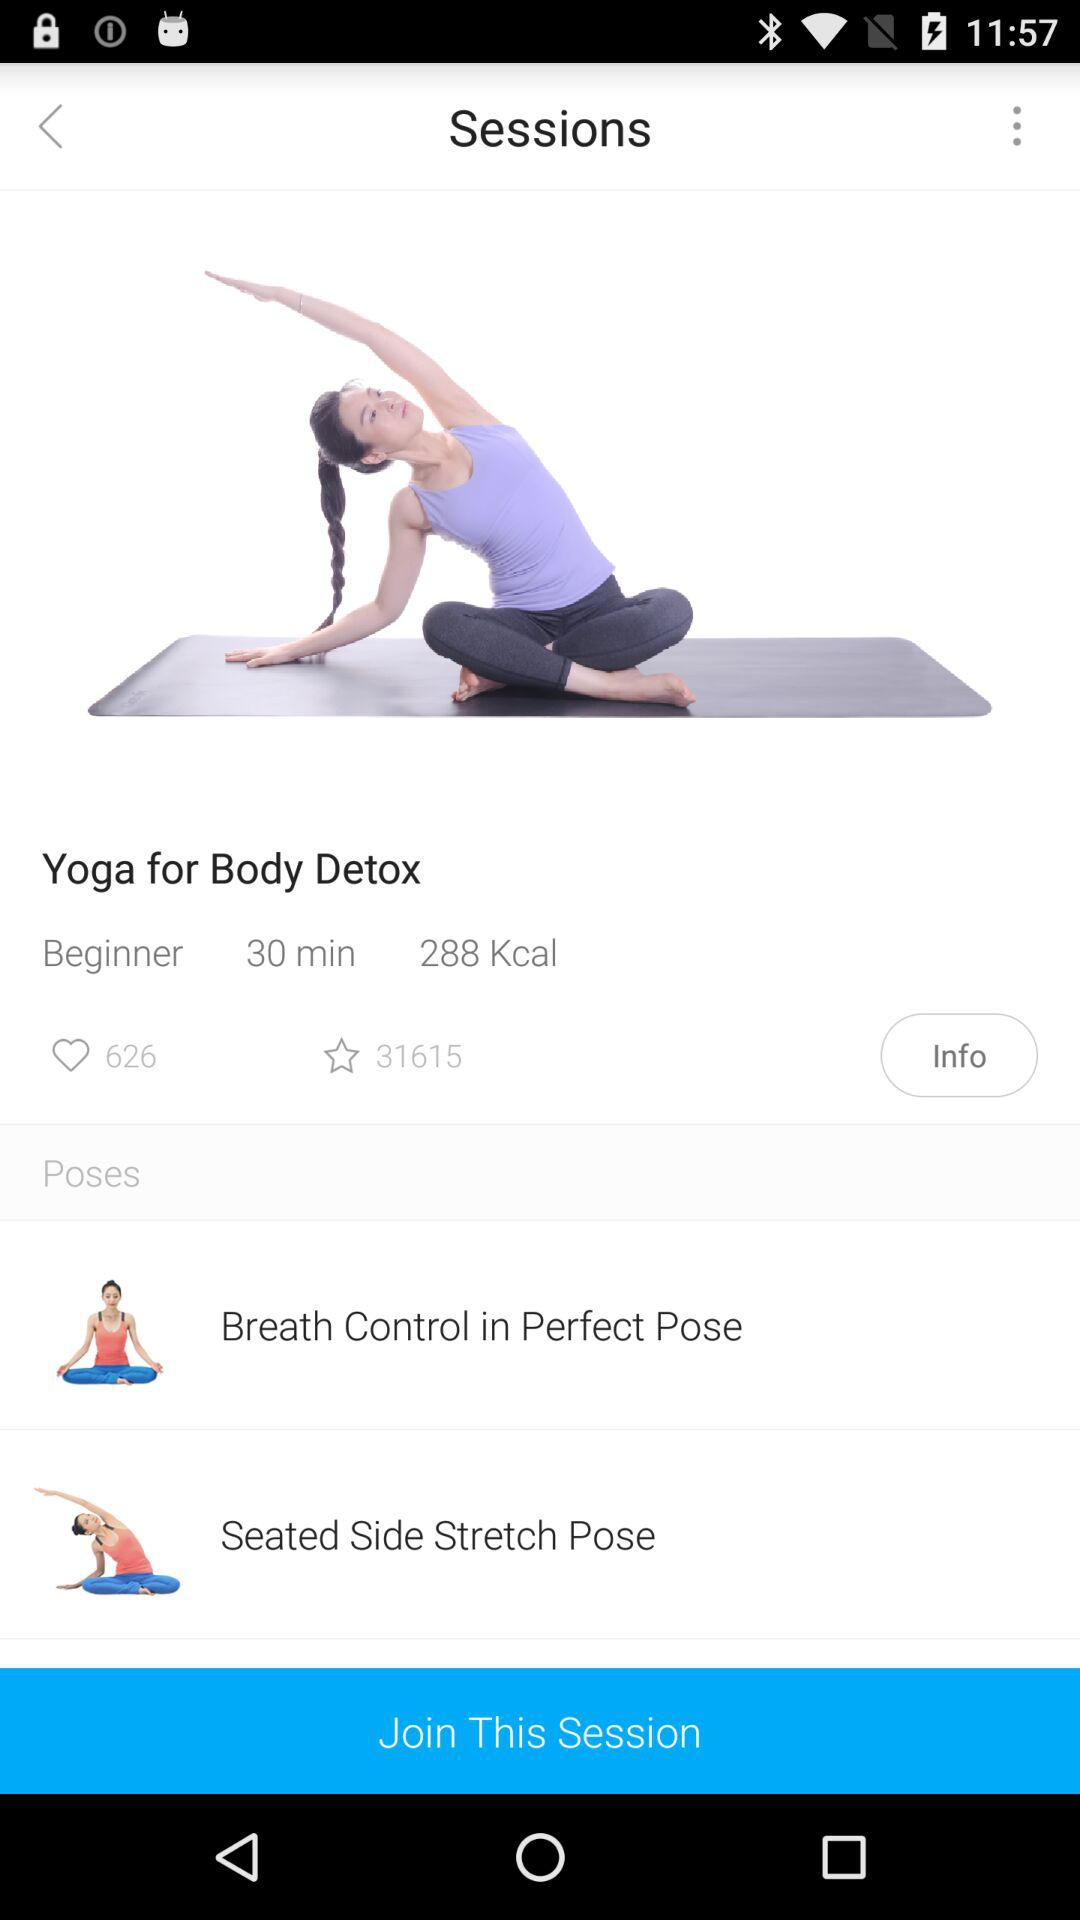How many poses are available?
When the provided information is insufficient, respond with <no answer>. <no answer> 